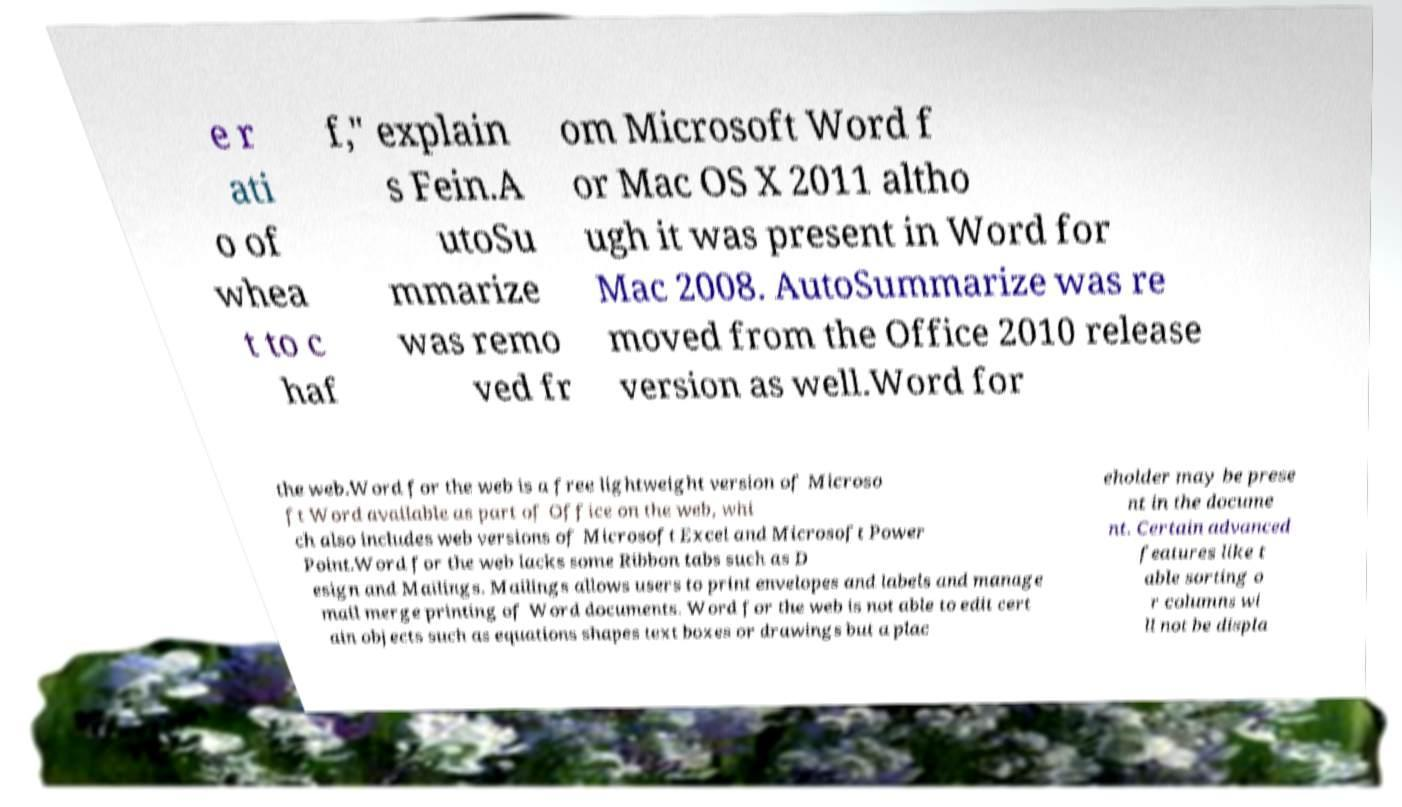For documentation purposes, I need the text within this image transcribed. Could you provide that? e r ati o of whea t to c haf f," explain s Fein.A utoSu mmarize was remo ved fr om Microsoft Word f or Mac OS X 2011 altho ugh it was present in Word for Mac 2008. AutoSummarize was re moved from the Office 2010 release version as well.Word for the web.Word for the web is a free lightweight version of Microso ft Word available as part of Office on the web, whi ch also includes web versions of Microsoft Excel and Microsoft Power Point.Word for the web lacks some Ribbon tabs such as D esign and Mailings. Mailings allows users to print envelopes and labels and manage mail merge printing of Word documents. Word for the web is not able to edit cert ain objects such as equations shapes text boxes or drawings but a plac eholder may be prese nt in the docume nt. Certain advanced features like t able sorting o r columns wi ll not be displa 